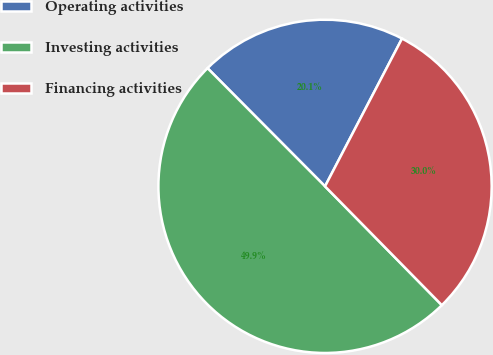Convert chart to OTSL. <chart><loc_0><loc_0><loc_500><loc_500><pie_chart><fcel>Operating activities<fcel>Investing activities<fcel>Financing activities<nl><fcel>20.1%<fcel>49.91%<fcel>29.99%<nl></chart> 